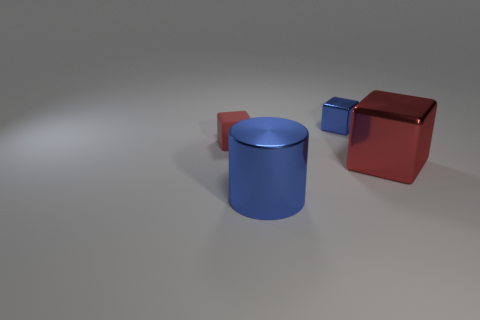What color is the object that is to the left of the big metal object to the left of the small object behind the tiny red rubber thing?
Offer a very short reply. Red. Do the large cylinder and the rubber block have the same color?
Provide a short and direct response. No. What number of things are the same size as the metal cylinder?
Offer a very short reply. 1. Is the number of big cylinders that are behind the small blue metal block greater than the number of things to the right of the big blue cylinder?
Give a very brief answer. No. There is a metallic block behind the small object that is in front of the blue shiny block; what is its color?
Give a very brief answer. Blue. Are the large cylinder and the large cube made of the same material?
Keep it short and to the point. Yes. Are there any other large shiny things that have the same shape as the red metal object?
Your response must be concise. No. Do the big thing that is in front of the large red metal thing and the tiny metal block have the same color?
Provide a succinct answer. Yes. There is a red block to the left of the big red shiny object; is it the same size as the blue metal thing that is in front of the red metallic block?
Your answer should be very brief. No. What is the size of the blue cylinder that is made of the same material as the large red block?
Provide a succinct answer. Large. 